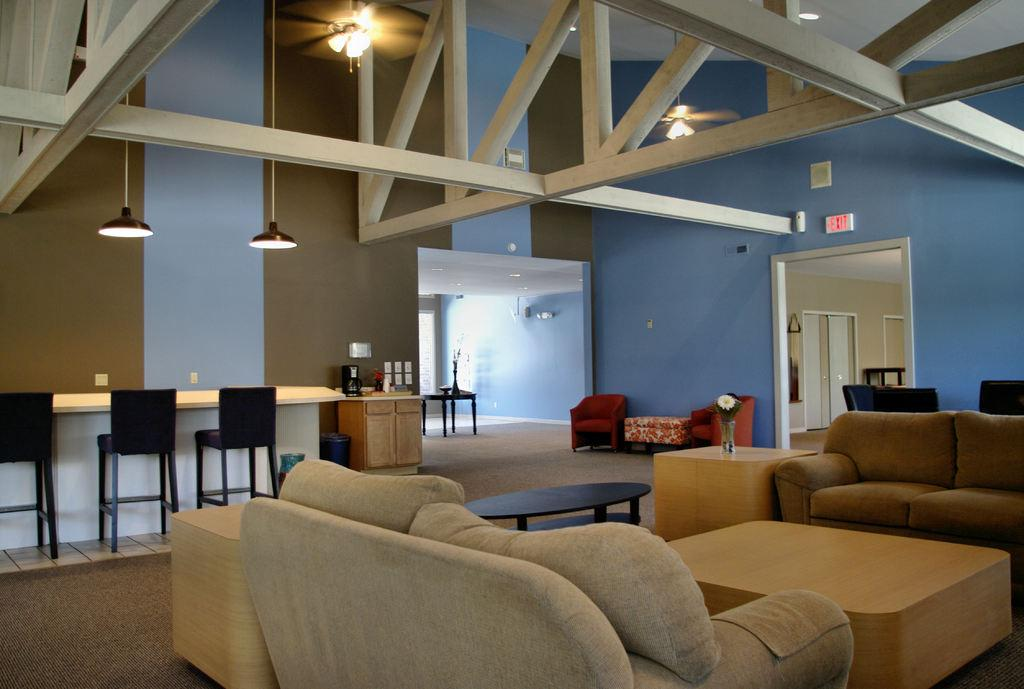What type of room is depicted in the image? There is a hall in the image. What furniture can be seen in the hall? There is a couch, a teapoy, chairs, a flower vase, lights, a cupboard, and a table in the hall. Can you describe the arrangement of the furniture in the hall? The furniture is arranged in a way that allows for comfortable seating and storage, with the couch, chairs, and table forming a seating area, and the teapoy, cupboard, and table providing additional surfaces for display or storage. What type of nose can be seen on the teapoy in the image? There is no nose present on the teapoy in the image. What type of breakfast is being served on the table in the image? There is no breakfast visible in the image; the table is empty. 